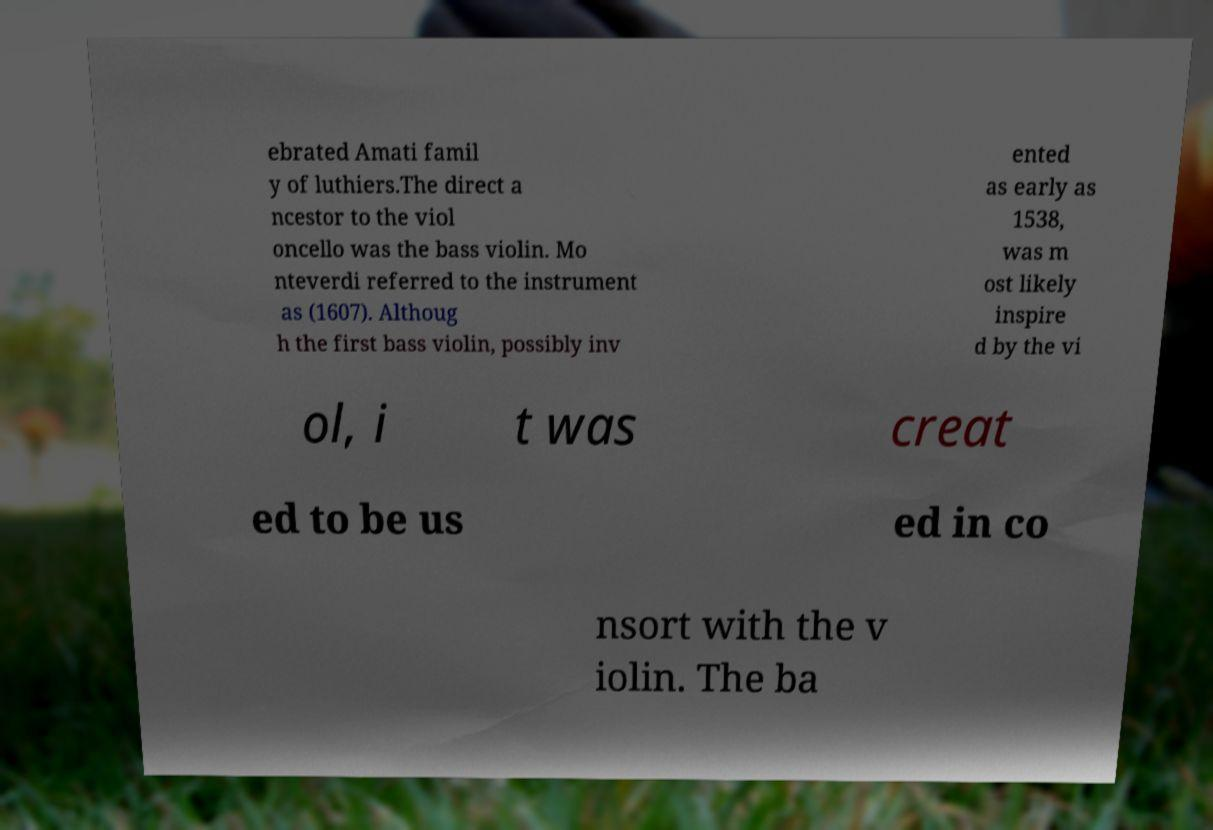For documentation purposes, I need the text within this image transcribed. Could you provide that? ebrated Amati famil y of luthiers.The direct a ncestor to the viol oncello was the bass violin. Mo nteverdi referred to the instrument as (1607). Althoug h the first bass violin, possibly inv ented as early as 1538, was m ost likely inspire d by the vi ol, i t was creat ed to be us ed in co nsort with the v iolin. The ba 